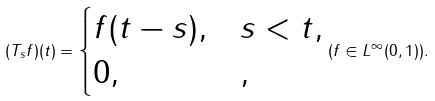Convert formula to latex. <formula><loc_0><loc_0><loc_500><loc_500>( T _ { s } f ) ( t ) = \begin{cases} f ( t - s ) , & s < t , \\ 0 , & , \end{cases} ( f \in L ^ { \infty } ( 0 , 1 ) ) .</formula> 